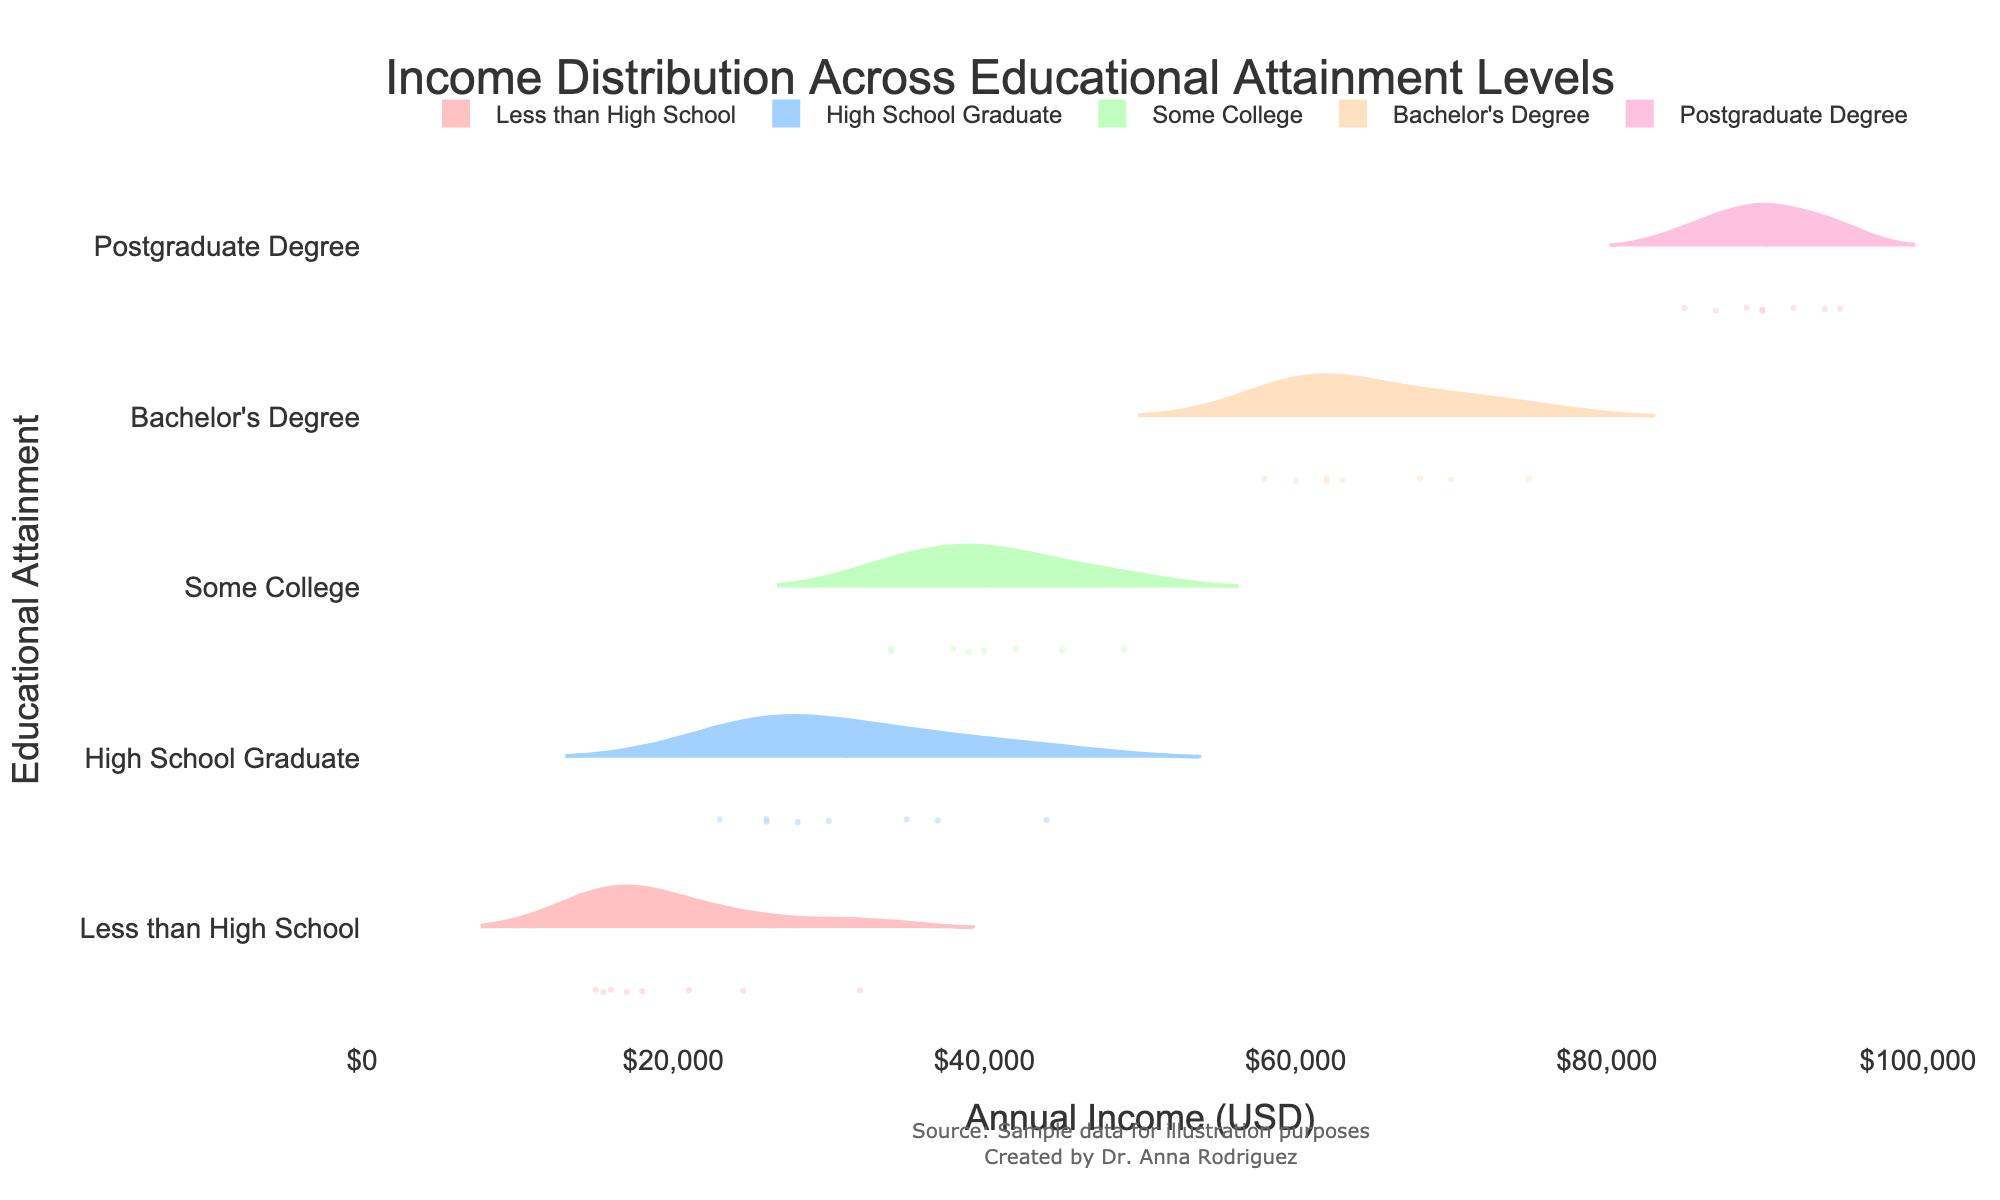What is the title of the chart? The title of the chart is usually located at the top. Based on the given code, the title is "Income Distribution Across Educational Attainment Levels."
Answer: Income Distribution Across Educational Attainment Levels What does the x-axis represent? The x-axis in the chart represents the variable that is plotted horizontally. According to the given code, the x-axis title is "Annual Income (USD)."
Answer: Annual Income (USD) Which educational attainment level shows the widest range of income? To determine which group shows the widest range, observe the width of the violins for each educational level. The group with the widest horizontal span is "Postgraduate Degree."
Answer: Postgraduate Degree What is the median income for individuals with a Bachelor's Degree? In a violin plot, the median is often represented by a line across the violin. For those with a Bachelor's Degree, the median line is around $62,000.
Answer: $62,000 Which educational attainment has the highest median income? By comparing the median lines (visible on the plot as horizontal lines), the group with the highest median is "Postgraduate Degree."
Answer: Postgraduate Degree How does the spread of income for "Some College" compare to "High School Graduate"? To compare the spread, examine the width of the violins. The "Some College" group has a wider range, indicating more variation in income compared to "High School Graduate."
Answer: More variation in "Some College" Which group has the smallest range of income? The smallest range can be found by looking at the narrowest violin. "Less than High School" appears to have the smallest range.
Answer: Less than High School Is there an overlap in income between "Bachelor's Degree" and "Postgraduate Degree"? To identify overlaps, check the ranges of the horizontal violins. There is an overlap in the income distributions of "Bachelor's Degree" and "Postgraduate Degree."
Answer: Yes What is the lowest observed income in the dataset? Examine the leftmost point of the violins in the plot. The lowest income, as observed in the "Less than High School" category, is $15,000.
Answer: $15,000 What insights can be drawn about the relationship between educational attainment and income? Higher educational attainment is generally associated with higher incomes. The median income and the range increase with higher levels of education.
Answer: Higher education, higher income 